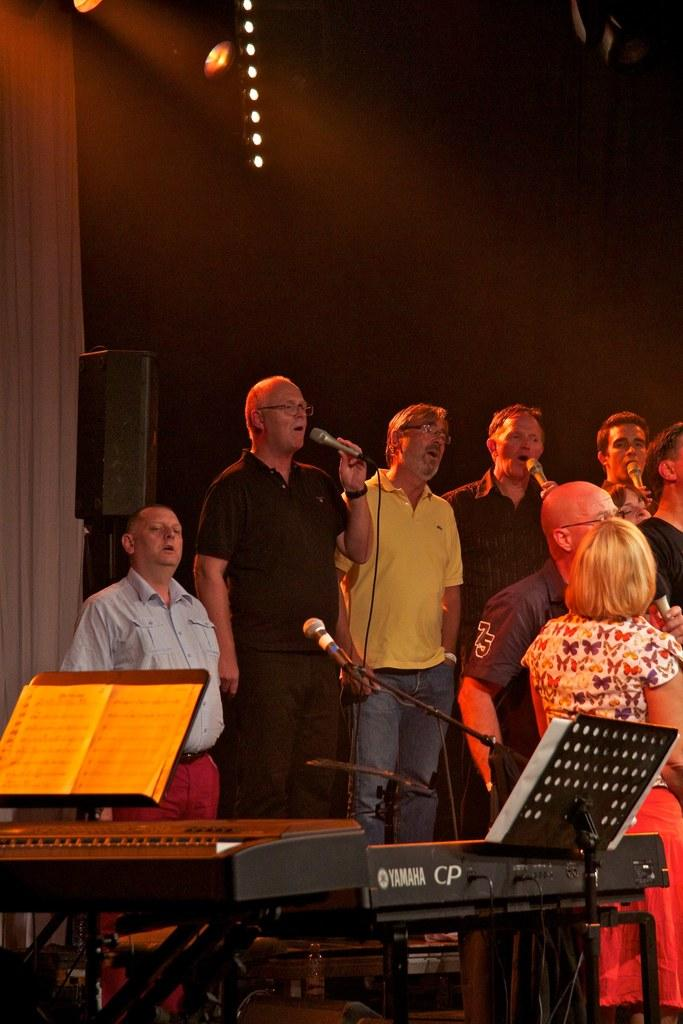Provide a one-sentence caption for the provided image. A group of people singing behind a Yamaha piano. 